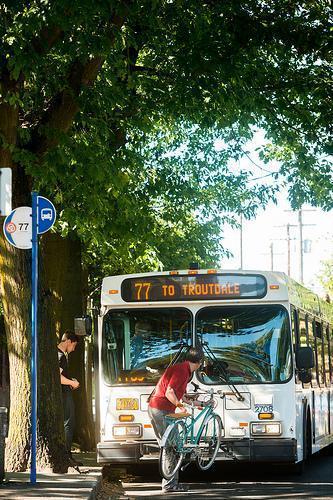How many people are outside the bus?
Give a very brief answer. 2. How many people are holding a bike?
Give a very brief answer. 1. 